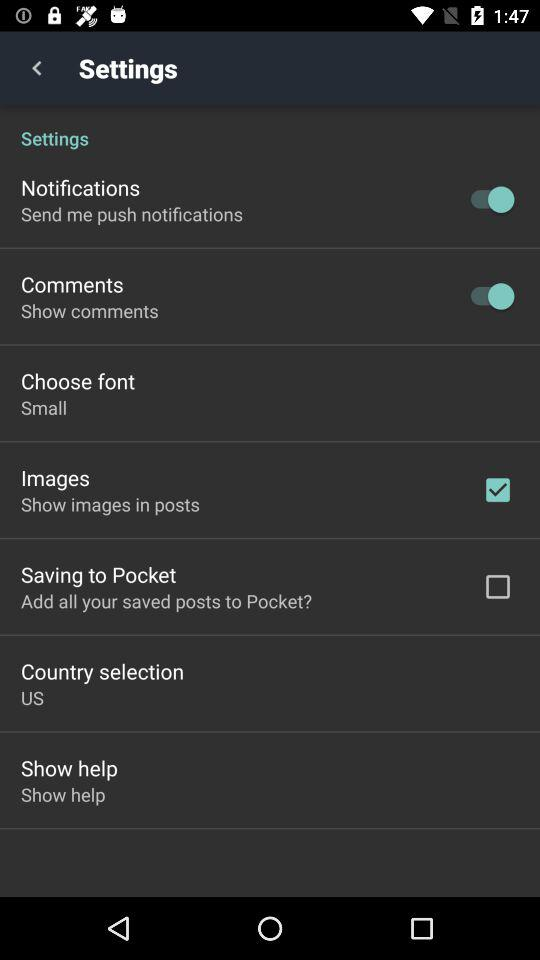What is the status of "Images"? The status of "Images" is "on". 